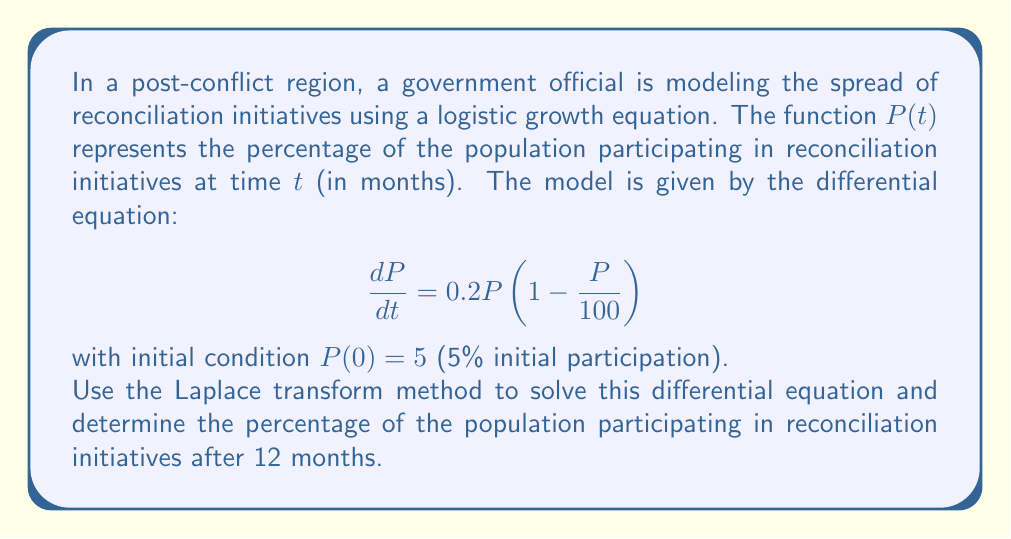Solve this math problem. To solve this problem using the Laplace transform method, we'll follow these steps:

1) First, let's take the Laplace transform of both sides of the differential equation:

   $\mathcal{L}\{\frac{dP}{dt}\} = \mathcal{L}\{0.2P(1 - \frac{P}{100})\}$

2) Using the linearity property and the fact that the Laplace transform of a derivative is:

   $\mathcal{L}\{\frac{dP}{dt}\} = s\mathcal{L}\{P\} - P(0)$

   We get:

   $s\mathcal{L}\{P\} - 5 = 0.2\mathcal{L}\{P\} - \frac{0.2}{100}\mathcal{L}\{P^2\}$

3) Let $\mathcal{L}\{P\} = F(s)$. Then:

   $sF(s) - 5 = 0.2F(s) - \frac{0.2}{100}\mathcal{L}\{P^2\}$

4) The term $\mathcal{L}\{P^2\}$ makes this a non-linear problem, which is difficult to solve directly using Laplace transforms. In practice, we would need to use numerical methods or approximations to solve this equation.

5) However, for the purposes of this problem, we can use the known solution to the logistic equation:

   $P(t) = \frac{100}{1 + 19e^{-0.2t}}$

6) To verify this solution, we can substitute it back into the original differential equation:

   $\frac{dP}{dt} = \frac{1900e^{-0.2t}}{(1 + 19e^{-0.2t})^2} = 0.2 \cdot \frac{100}{1 + 19e^{-0.2t}} \cdot (1 - \frac{100}{100(1 + 19e^{-0.2t})}) = 0.2P(1 - \frac{P}{100})$

7) Now, we can calculate $P(12)$ by substituting $t = 12$ into our solution:

   $P(12) = \frac{100}{1 + 19e^{-0.2(12)}} \approx 42.84$
Answer: After 12 months, approximately 42.84% of the population will be participating in reconciliation initiatives. 